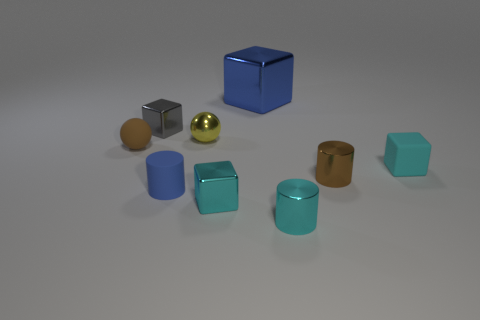Is there any other thing that is the same size as the blue cube?
Your answer should be very brief. No. What number of cylinders are behind the blue rubber object?
Provide a short and direct response. 1. What shape is the cyan thing that is behind the blue thing to the left of the big cube?
Keep it short and to the point. Cube. Are there more tiny cylinders to the right of the blue cylinder than tiny blue objects?
Keep it short and to the point. Yes. What number of blue matte cylinders are to the right of the tiny cylinder behind the blue cylinder?
Your response must be concise. 0. What is the shape of the object that is in front of the small cyan thing that is left of the small cyan shiny object that is right of the large block?
Give a very brief answer. Cylinder. What is the size of the blue metallic object?
Provide a short and direct response. Large. Is there a blue cylinder made of the same material as the small brown ball?
Keep it short and to the point. Yes. What is the size of the other cyan object that is the same shape as the small cyan matte object?
Make the answer very short. Small. Are there an equal number of cyan metallic cubes left of the small shiny sphere and small red metal blocks?
Provide a succinct answer. Yes. 